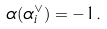<formula> <loc_0><loc_0><loc_500><loc_500>\alpha ( \alpha _ { i } ^ { \vee } ) = - 1 .</formula> 